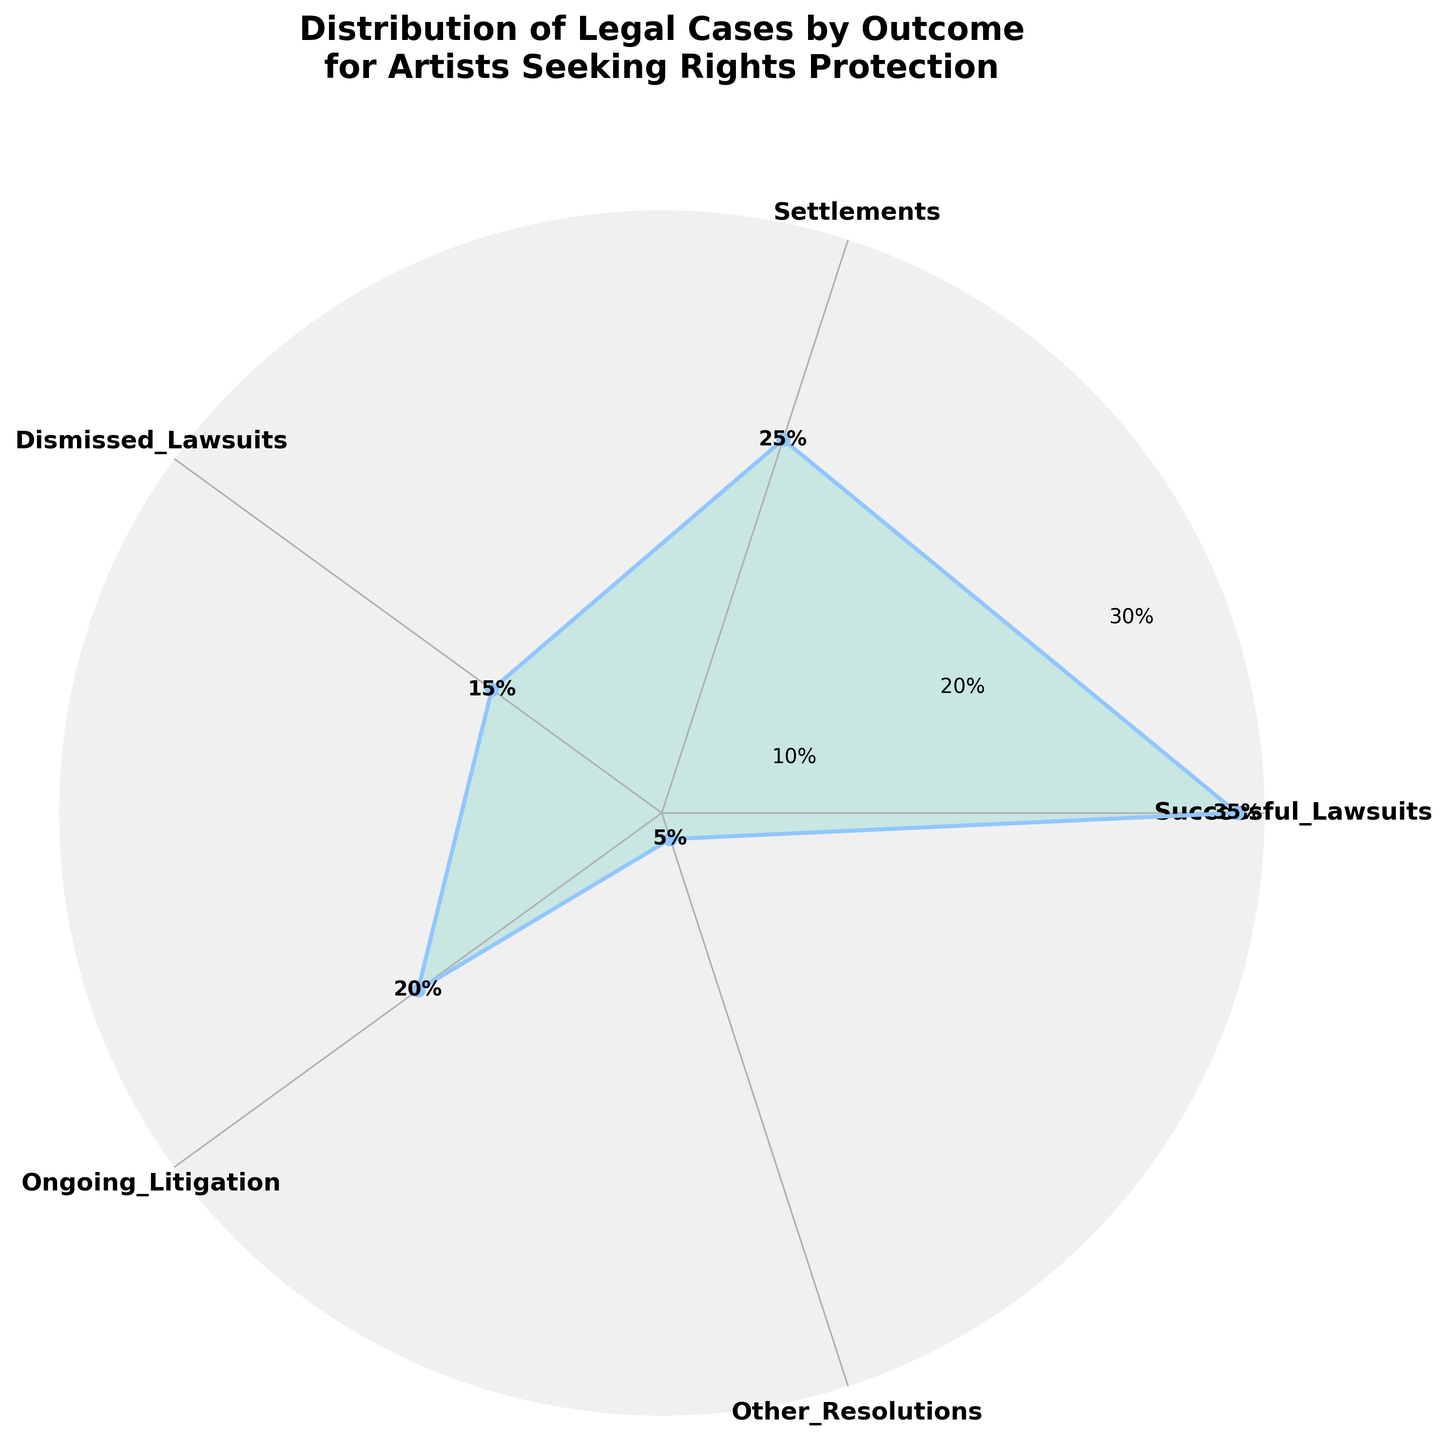what is the percentage of successful lawsuits? The figure shows a chart with various outcomes along with their respective percentage values. The value for "Successful Lawsuits" is displayed as a percentage.
Answer: 35% What is the smallest percentage outcome? The figure includes multiple outcomes with corresponding percentages. The smallest percentage value among them is labeled.
Answer: 5% How many different outcomes are displayed in the figure? The figure contains an equal number of sectors for each outcome listed. By counting these sectors/labels, you can determine the total number of outcomes.
Answer: 5 What is the combined percentage for Settlements and Ongoing Litigation? The percentages for Settlements and Ongoing Litigation are given in the figure. Adding these values (25% + 20%) provides the combined percentage.
Answer: 45% Which outcome has a higher percentage, Dismissed Lawsuits or Ongoing Litigation? The figure shows the percentage for both Dismissed Lawsuits and Ongoing Litigation. Comparing these two values (Dismissed Lawsuits: 15%, Ongoing Litigation: 20%) reveals which one is higher.
Answer: Ongoing Litigation What percentage of cases were either Dismissed or fell under Other Resolutions? The percentages for Dismissed Lawsuits and Other Resolutions are given in the figure. Adding these values (15% + 5%) provides the combined percentage.
Answer: 20% Which outcome has the largest segment in the figure? The figure displays segments for each outcome, with larger segments representing higher percentages. The segment labeled "Successful Lawsuits" appears largest.
Answer: Successful Lawsuits What is the difference in percentage between the highest and lowest outcome percentages? The highest percentage is for Successful Lawsuits (35%), and the lowest is for Other Resolutions (5%). Subtracting these values (35% - 5%) gives the difference.
Answer: 30% Are there more cases that were settled than those that are ongoing? The figure shows the percentages for Settlements (25%) and Ongoing Litigation (20%). Comparing these values reveals that Settlements have a higher percentage.
Answer: Yes 